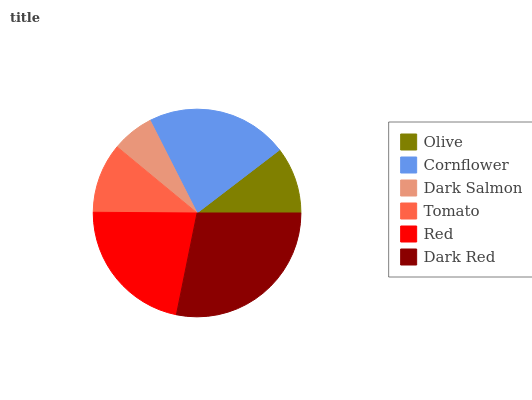Is Dark Salmon the minimum?
Answer yes or no. Yes. Is Dark Red the maximum?
Answer yes or no. Yes. Is Cornflower the minimum?
Answer yes or no. No. Is Cornflower the maximum?
Answer yes or no. No. Is Cornflower greater than Olive?
Answer yes or no. Yes. Is Olive less than Cornflower?
Answer yes or no. Yes. Is Olive greater than Cornflower?
Answer yes or no. No. Is Cornflower less than Olive?
Answer yes or no. No. Is Red the high median?
Answer yes or no. Yes. Is Tomato the low median?
Answer yes or no. Yes. Is Dark Red the high median?
Answer yes or no. No. Is Cornflower the low median?
Answer yes or no. No. 